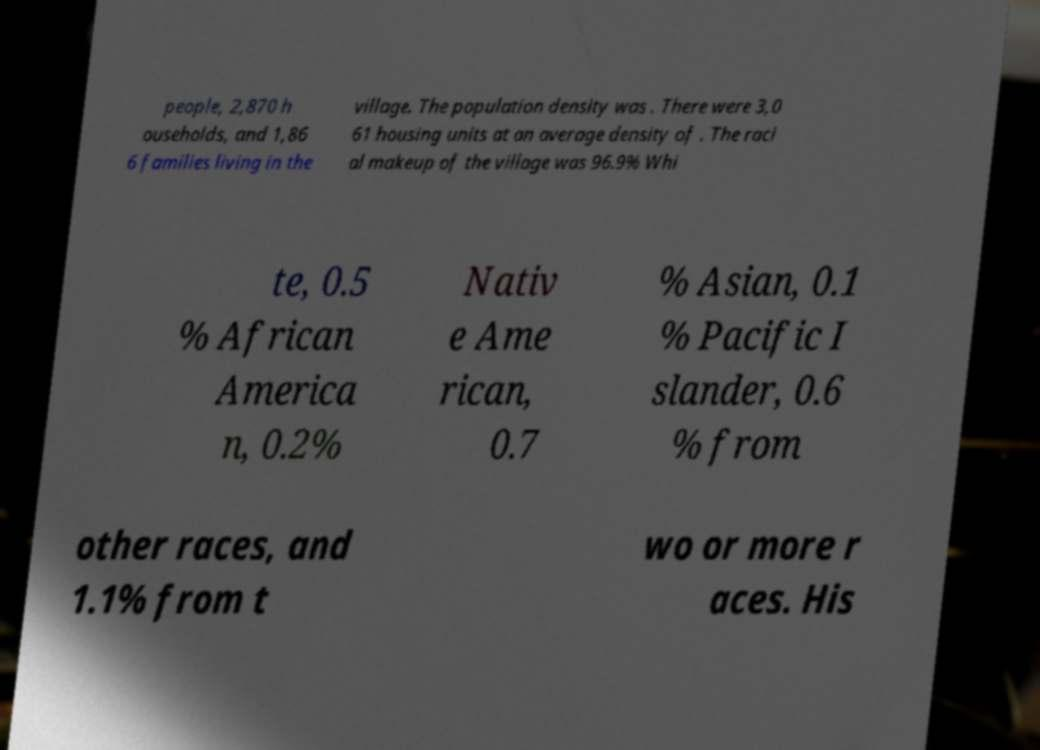Please read and relay the text visible in this image. What does it say? people, 2,870 h ouseholds, and 1,86 6 families living in the village. The population density was . There were 3,0 61 housing units at an average density of . The raci al makeup of the village was 96.9% Whi te, 0.5 % African America n, 0.2% Nativ e Ame rican, 0.7 % Asian, 0.1 % Pacific I slander, 0.6 % from other races, and 1.1% from t wo or more r aces. His 